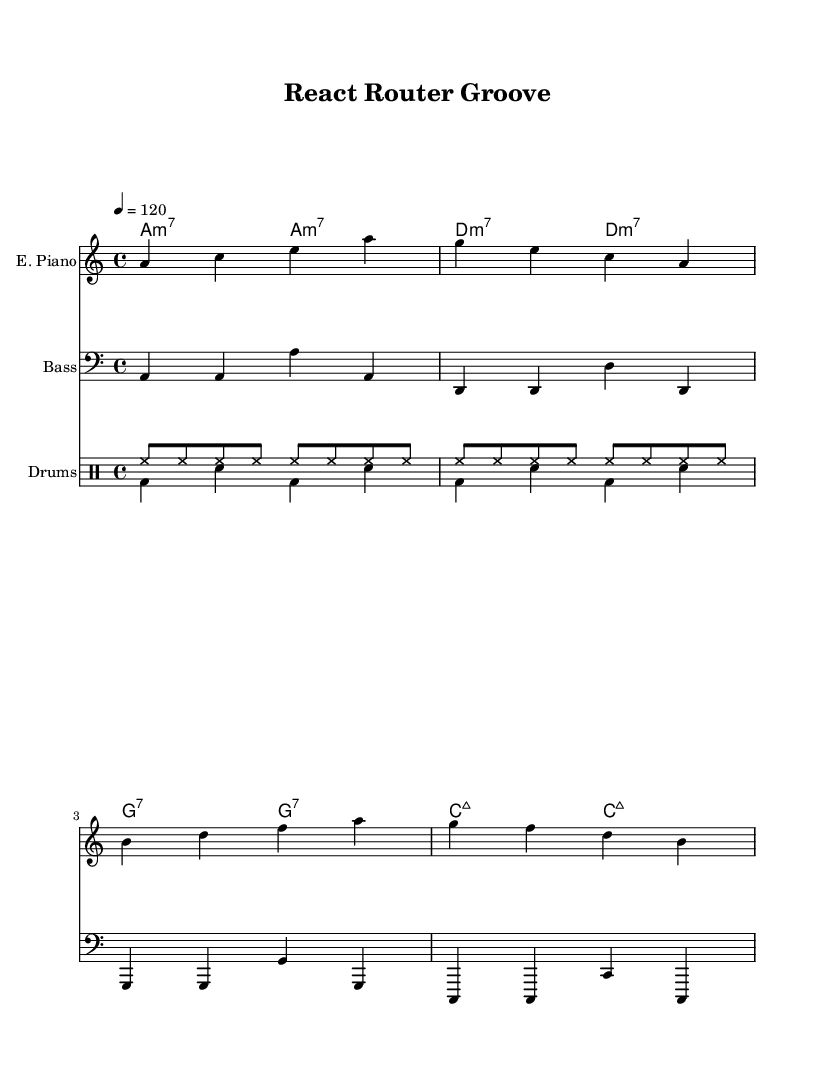What is the key signature of this music? The key signature is A minor, which has no sharps or flats (it's the relative minor of C major). This can be confirmed by the presence of the A at the beginning of the staff.
Answer: A minor What is the time signature of this piece? The time signature is 4/4, indicated at the beginning of the score. This means there are four beats per measure and the quarter note gets one beat.
Answer: 4/4 What is the tempo marking for this piece? The tempo marking is indicated with a metronome marking of 120 beats per minute. This sets the speed at which the music should be played, shown by the notation "4 = 120".
Answer: 120 How many measures are in the electric piano part? The electric piano part consists of four measures, as it features four distinct groups of notes separated by vertical lines. Each line signifies the end of a measure.
Answer: 4 Which instrument has the highest pitch in this score? The instrument with the highest pitch is the electric piano, represented by the treble clef, allowing it to play the upper range of notes.
Answer: Electric Piano What type of chords are used in the chord section? The chords used in the chord section include minor 7th chords and major 7th chords, as noted by the chord names that include "m7" and "maj7".
Answer: Minor 7th and Major 7th How many different drum voices are present in the drum staff? There are two different drum voices in the drum staff, as indicated by the notation for both the hi-hat and bass drum sections. This shows the rhythm and layering in the drum part.
Answer: 2 